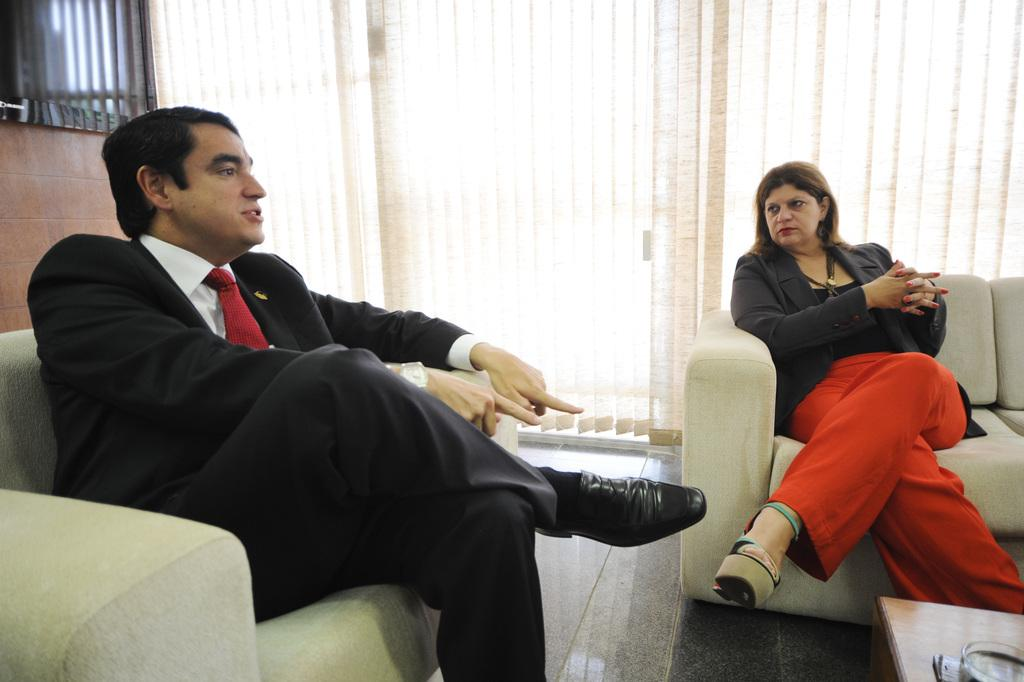What is the man in the image doing? The man is sitting on a sofa and speaking. Who is with the man in the image? There is a woman beside the man. What is the woman doing in the image? The woman is listening to the man. What type of sleet is falling outside the window in the image? There is no window or mention of sleet in the image; it only shows a man sitting on a sofa and speaking, with a woman beside him listening. 